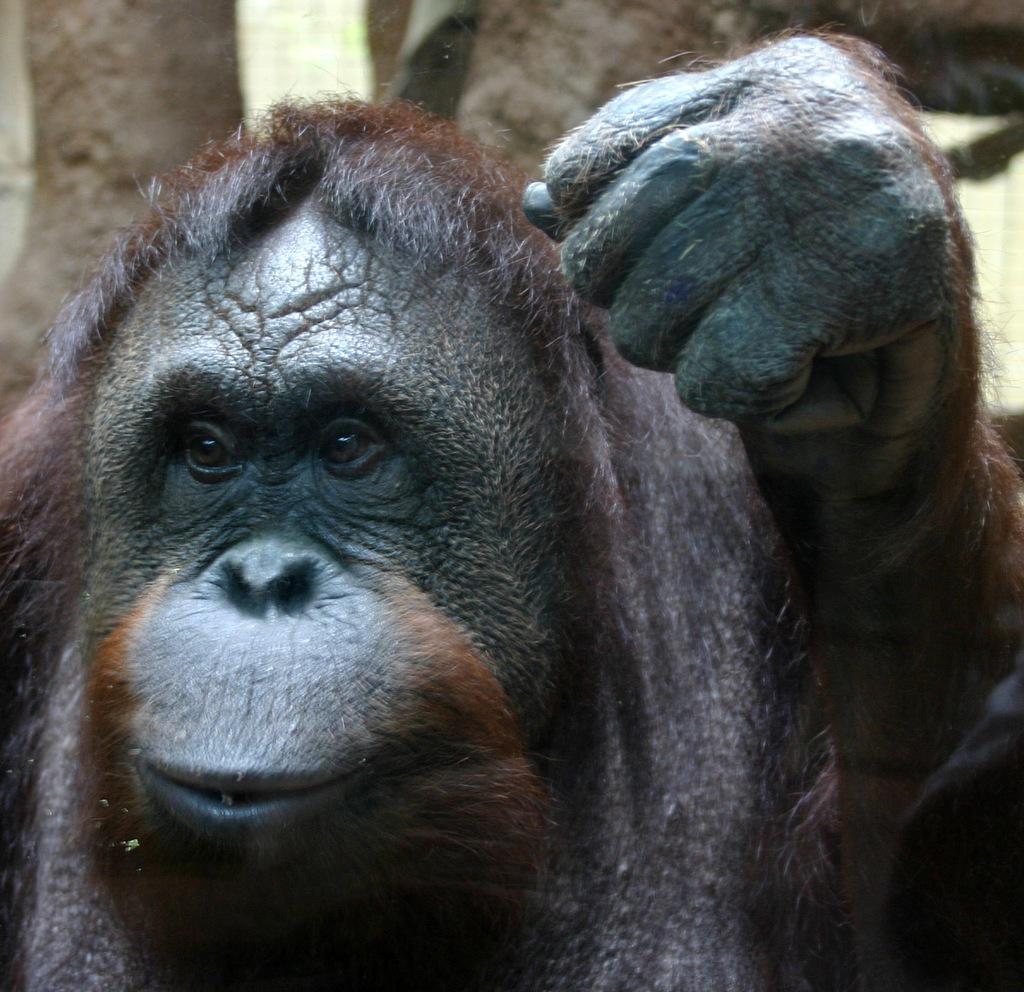Describe this image in one or two sentences. In this image we can see an animal which is in black color. Behind the animal we can see few objects. 